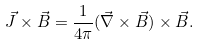<formula> <loc_0><loc_0><loc_500><loc_500>\vec { J } \times \vec { B } = \frac { 1 } { 4 \pi } ( \vec { \nabla } \times \vec { B } ) \times \vec { B } .</formula> 